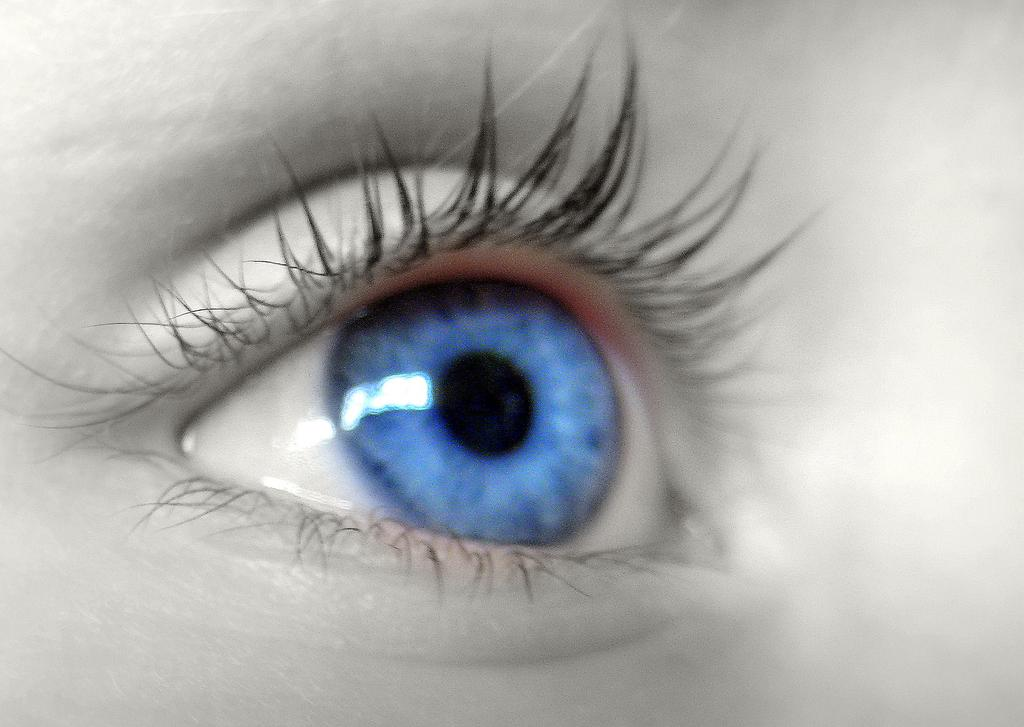What is the main subject of the image? The main subject of the image is a human eye. What type of gun is being used to stop the cart in the image? There is: There is no gun, cart, or any action of stopping in the image; it only features a human eye. 